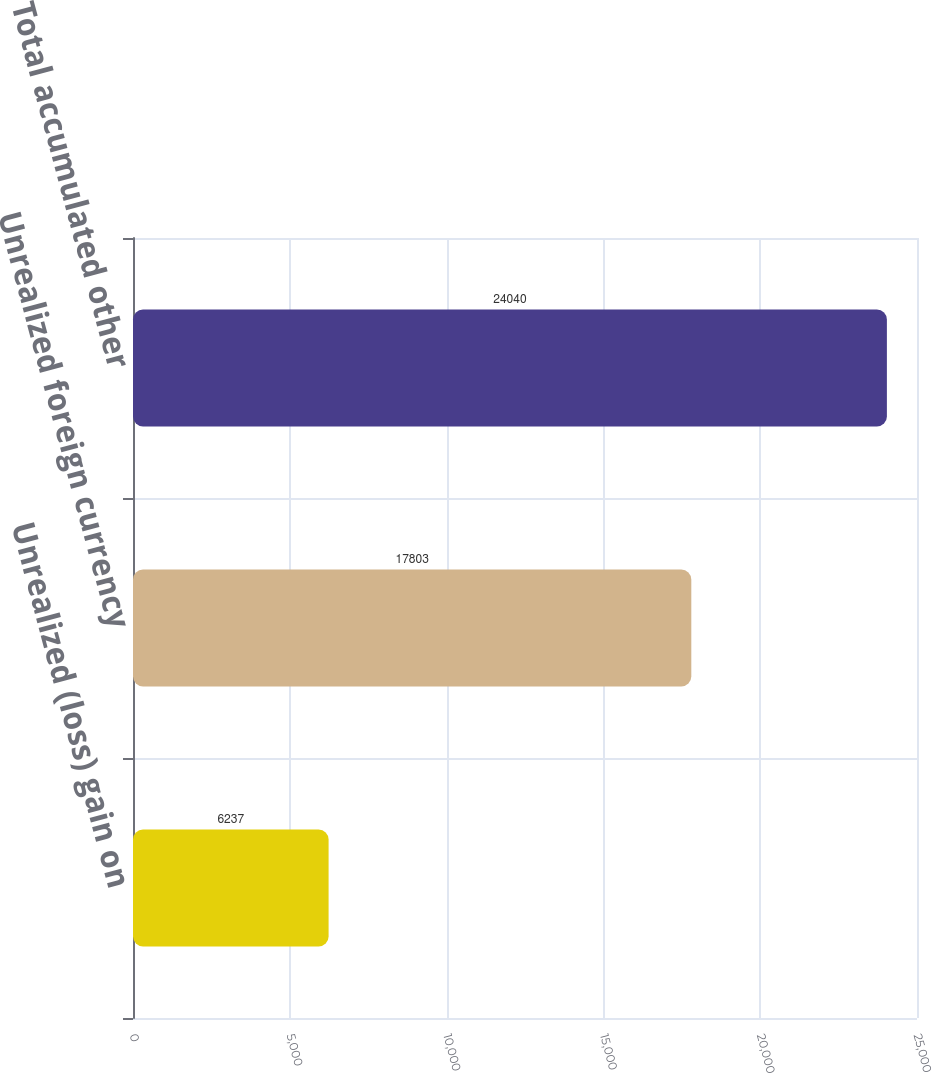<chart> <loc_0><loc_0><loc_500><loc_500><bar_chart><fcel>Unrealized (loss) gain on<fcel>Unrealized foreign currency<fcel>Total accumulated other<nl><fcel>6237<fcel>17803<fcel>24040<nl></chart> 